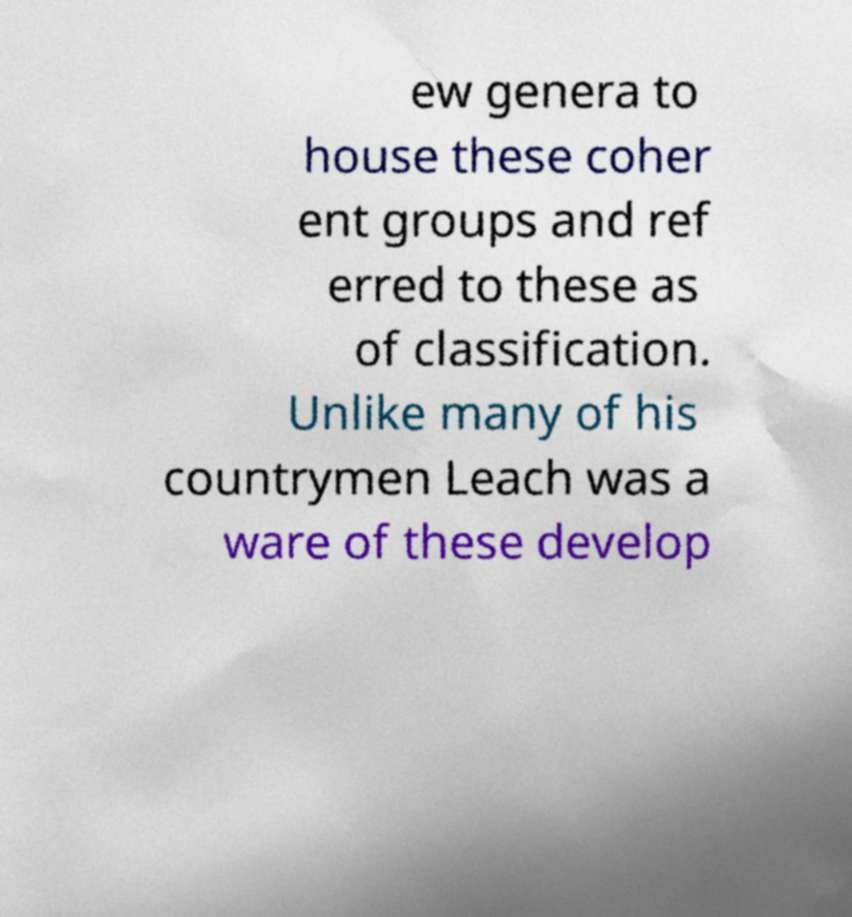I need the written content from this picture converted into text. Can you do that? ew genera to house these coher ent groups and ref erred to these as of classification. Unlike many of his countrymen Leach was a ware of these develop 